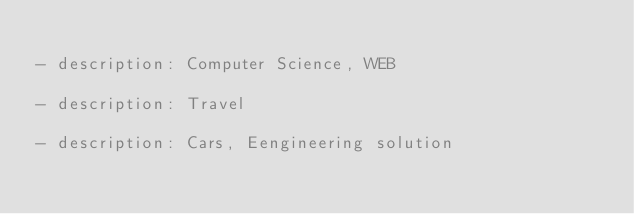<code> <loc_0><loc_0><loc_500><loc_500><_YAML_>
- description: Computer Science, WEB

- description: Travel

- description: Cars, Eengineering solution

</code> 